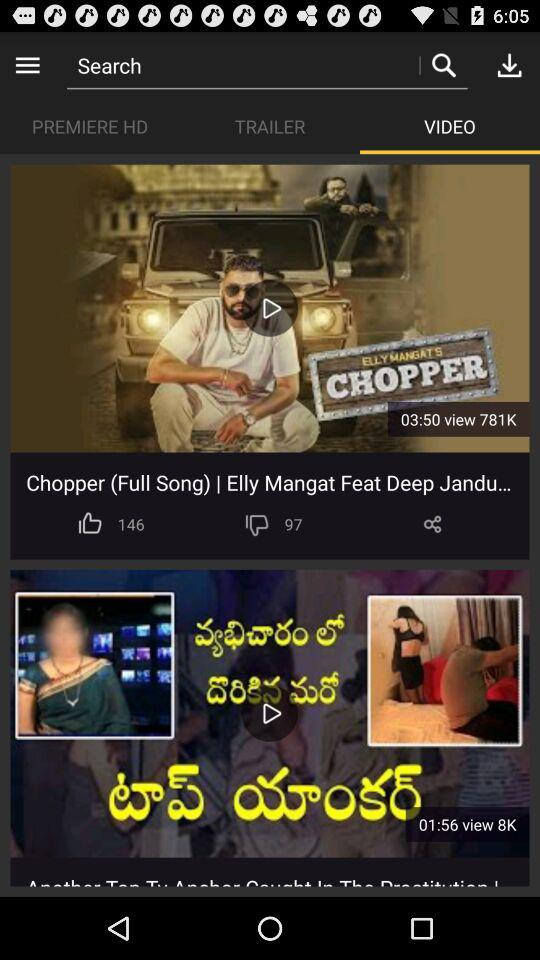Which tab is selected? The selected tab is "VIDEO". 